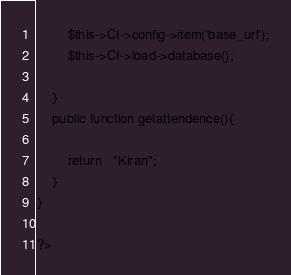Convert code to text. <code><loc_0><loc_0><loc_500><loc_500><_PHP_>        $this->CI->config->item('base_url');
        $this->CI->load->database();
        
    }
	public function getattendence(){
       
	    return   "Kiran";
	}
}

?></code> 